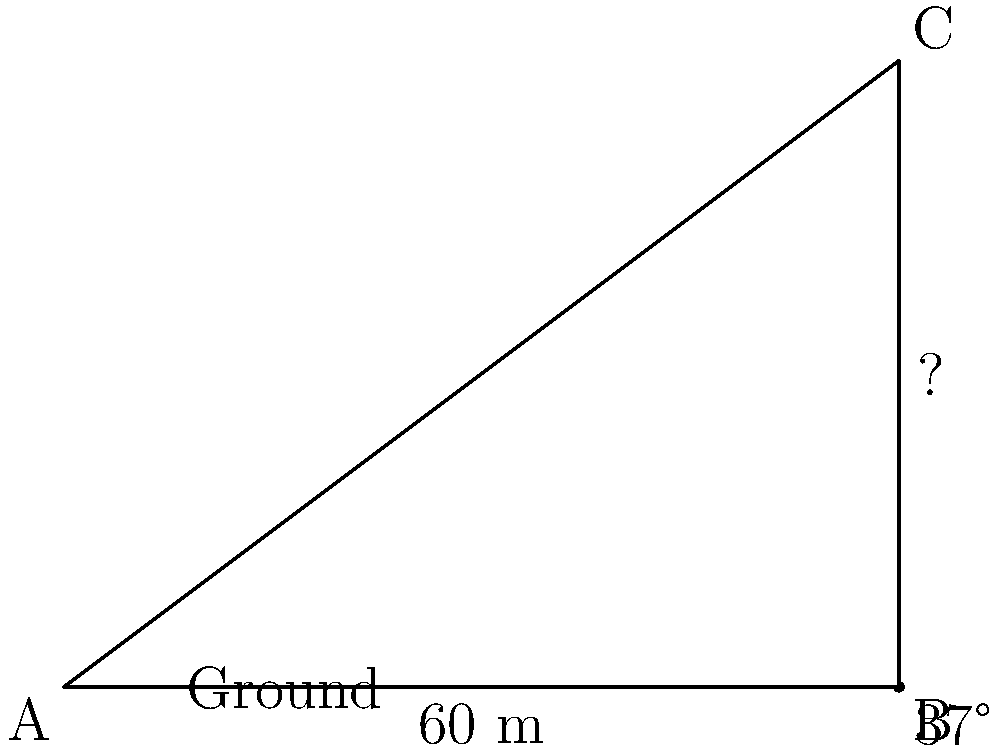As a nurse at Glasgow Royal Infirmary, you're tasked with estimating the height of the hospital's new wing for emergency planning purposes. Standing 60 meters away from the base of the building, you use a clinometer and measure the angle of elevation to the top of the building to be 37°. Calculate the height of the new hospital wing to the nearest meter. Let's approach this step-by-step using trigonometry:

1) We can model this situation as a right-angled triangle, where:
   - The adjacent side is the distance from you to the building (60 m)
   - The opposite side is the height of the building (what we're trying to find)
   - The angle of elevation is 37°

2) In a right-angled triangle, we can use the tangent function to find the ratio of the opposite side to the adjacent side:

   $\tan(\theta) = \frac{\text{opposite}}{\text{adjacent}}$

3) In our case:

   $\tan(37°) = \frac{\text{height}}{60}$

4) To find the height, we multiply both sides by 60:

   $60 \cdot \tan(37°) = \text{height}$

5) Now, let's calculate:

   $\text{height} = 60 \cdot \tan(37°)$
   $= 60 \cdot 0.7535$
   $= 45.21$ meters

6) Rounding to the nearest meter:

   $\text{height} \approx 45$ meters

Therefore, the height of the new hospital wing is approximately 45 meters.
Answer: 45 meters 